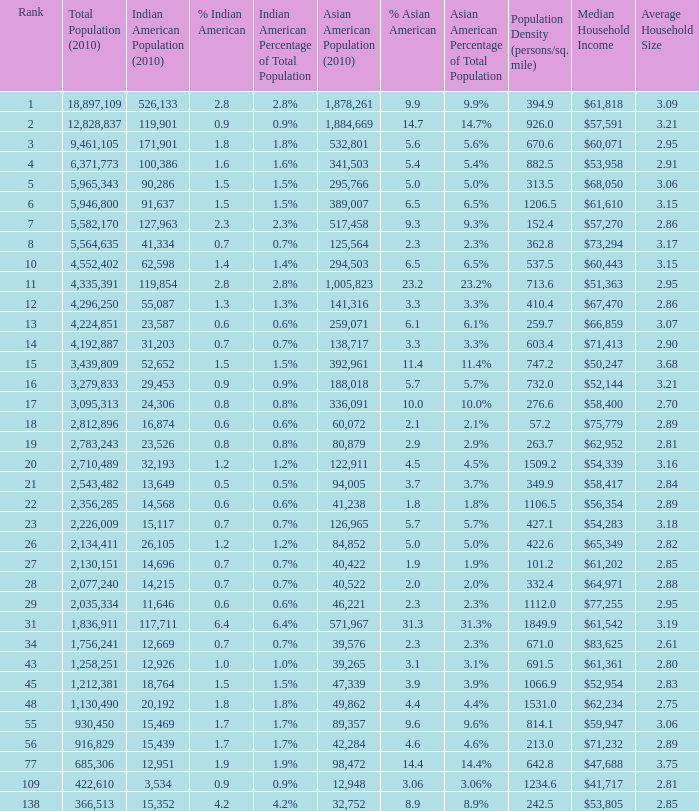What's the total population when there are 5.7% Asian American and fewer than 126,965 Asian American Population? None. 